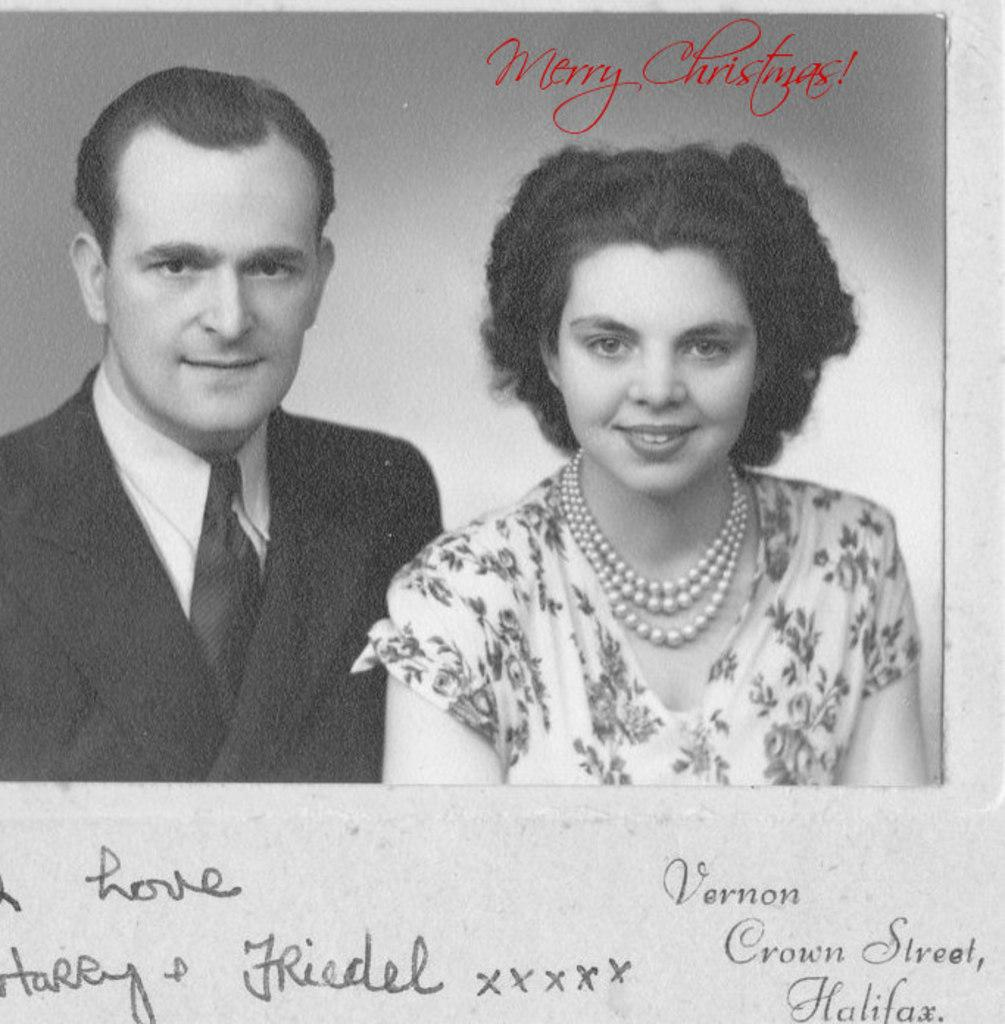How many people are in the image? There are two persons in the center of the image. What can be seen at the bottom of the image? There is some text at the bottom of the image. What type of pipe is being used by the persons in the image? There is no pipe visible in the image; it only features two persons and some text at the bottom. How many cars are present in the image? There are no cars present in the image. 